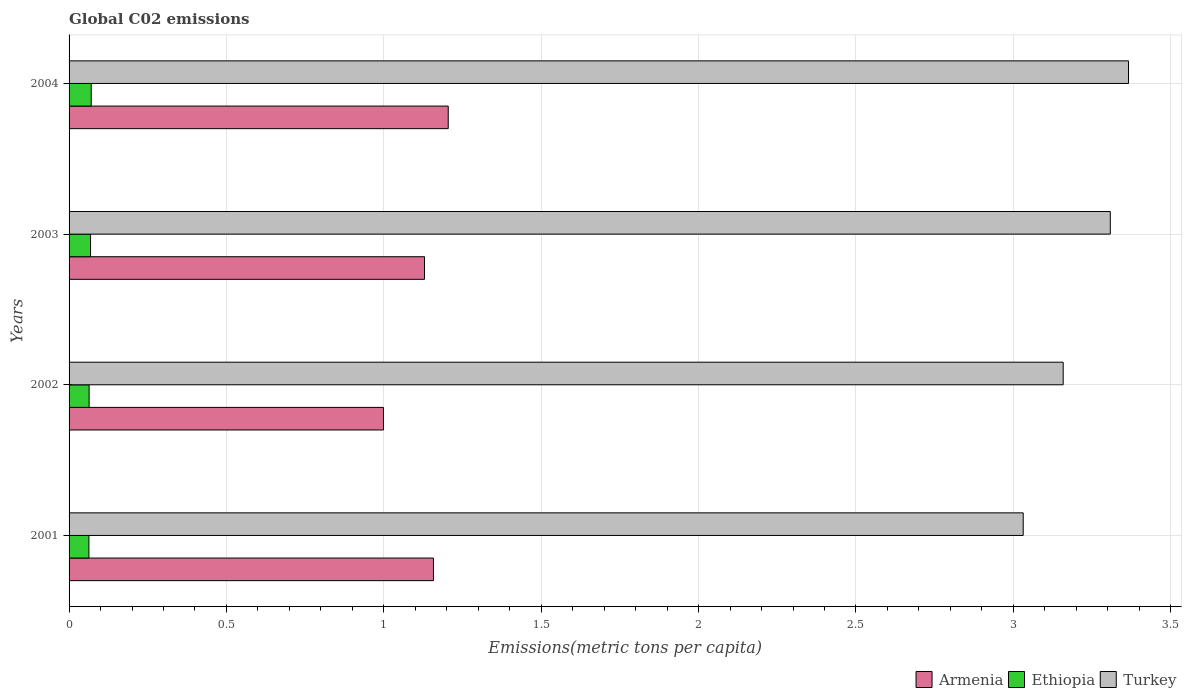How many groups of bars are there?
Your answer should be very brief. 4. Are the number of bars per tick equal to the number of legend labels?
Give a very brief answer. Yes. Are the number of bars on each tick of the Y-axis equal?
Give a very brief answer. Yes. How many bars are there on the 4th tick from the top?
Your answer should be very brief. 3. In how many cases, is the number of bars for a given year not equal to the number of legend labels?
Provide a short and direct response. 0. What is the amount of CO2 emitted in in Turkey in 2004?
Your answer should be compact. 3.37. Across all years, what is the maximum amount of CO2 emitted in in Armenia?
Make the answer very short. 1.2. Across all years, what is the minimum amount of CO2 emitted in in Armenia?
Your answer should be compact. 1. In which year was the amount of CO2 emitted in in Ethiopia maximum?
Offer a terse response. 2004. In which year was the amount of CO2 emitted in in Armenia minimum?
Keep it short and to the point. 2002. What is the total amount of CO2 emitted in in Armenia in the graph?
Make the answer very short. 4.49. What is the difference between the amount of CO2 emitted in in Ethiopia in 2002 and that in 2003?
Your answer should be very brief. -0. What is the difference between the amount of CO2 emitted in in Turkey in 2004 and the amount of CO2 emitted in in Armenia in 2003?
Provide a short and direct response. 2.24. What is the average amount of CO2 emitted in in Ethiopia per year?
Give a very brief answer. 0.07. In the year 2004, what is the difference between the amount of CO2 emitted in in Turkey and amount of CO2 emitted in in Armenia?
Offer a terse response. 2.16. What is the ratio of the amount of CO2 emitted in in Ethiopia in 2002 to that in 2003?
Provide a succinct answer. 0.93. Is the amount of CO2 emitted in in Armenia in 2001 less than that in 2004?
Your answer should be very brief. Yes. What is the difference between the highest and the second highest amount of CO2 emitted in in Turkey?
Make the answer very short. 0.06. What is the difference between the highest and the lowest amount of CO2 emitted in in Ethiopia?
Ensure brevity in your answer.  0.01. In how many years, is the amount of CO2 emitted in in Turkey greater than the average amount of CO2 emitted in in Turkey taken over all years?
Offer a terse response. 2. Is the sum of the amount of CO2 emitted in in Turkey in 2001 and 2002 greater than the maximum amount of CO2 emitted in in Ethiopia across all years?
Your answer should be compact. Yes. What does the 3rd bar from the top in 2001 represents?
Make the answer very short. Armenia. What does the 1st bar from the bottom in 2002 represents?
Offer a terse response. Armenia. How many years are there in the graph?
Provide a succinct answer. 4. What is the difference between two consecutive major ticks on the X-axis?
Your response must be concise. 0.5. Are the values on the major ticks of X-axis written in scientific E-notation?
Your response must be concise. No. Does the graph contain any zero values?
Keep it short and to the point. No. Where does the legend appear in the graph?
Offer a terse response. Bottom right. How many legend labels are there?
Your answer should be compact. 3. How are the legend labels stacked?
Make the answer very short. Horizontal. What is the title of the graph?
Ensure brevity in your answer.  Global C02 emissions. What is the label or title of the X-axis?
Keep it short and to the point. Emissions(metric tons per capita). What is the label or title of the Y-axis?
Your answer should be very brief. Years. What is the Emissions(metric tons per capita) in Armenia in 2001?
Give a very brief answer. 1.16. What is the Emissions(metric tons per capita) of Ethiopia in 2001?
Provide a short and direct response. 0.06. What is the Emissions(metric tons per capita) in Turkey in 2001?
Offer a terse response. 3.03. What is the Emissions(metric tons per capita) in Armenia in 2002?
Give a very brief answer. 1. What is the Emissions(metric tons per capita) in Ethiopia in 2002?
Offer a terse response. 0.06. What is the Emissions(metric tons per capita) of Turkey in 2002?
Give a very brief answer. 3.16. What is the Emissions(metric tons per capita) of Armenia in 2003?
Your answer should be compact. 1.13. What is the Emissions(metric tons per capita) of Ethiopia in 2003?
Provide a succinct answer. 0.07. What is the Emissions(metric tons per capita) of Turkey in 2003?
Make the answer very short. 3.31. What is the Emissions(metric tons per capita) in Armenia in 2004?
Provide a succinct answer. 1.2. What is the Emissions(metric tons per capita) in Ethiopia in 2004?
Offer a very short reply. 0.07. What is the Emissions(metric tons per capita) in Turkey in 2004?
Provide a succinct answer. 3.37. Across all years, what is the maximum Emissions(metric tons per capita) of Armenia?
Your answer should be very brief. 1.2. Across all years, what is the maximum Emissions(metric tons per capita) in Ethiopia?
Your response must be concise. 0.07. Across all years, what is the maximum Emissions(metric tons per capita) of Turkey?
Your answer should be compact. 3.37. Across all years, what is the minimum Emissions(metric tons per capita) of Armenia?
Ensure brevity in your answer.  1. Across all years, what is the minimum Emissions(metric tons per capita) of Ethiopia?
Keep it short and to the point. 0.06. Across all years, what is the minimum Emissions(metric tons per capita) of Turkey?
Keep it short and to the point. 3.03. What is the total Emissions(metric tons per capita) in Armenia in the graph?
Provide a succinct answer. 4.49. What is the total Emissions(metric tons per capita) in Ethiopia in the graph?
Offer a very short reply. 0.27. What is the total Emissions(metric tons per capita) in Turkey in the graph?
Ensure brevity in your answer.  12.86. What is the difference between the Emissions(metric tons per capita) of Armenia in 2001 and that in 2002?
Your answer should be very brief. 0.16. What is the difference between the Emissions(metric tons per capita) in Ethiopia in 2001 and that in 2002?
Your answer should be very brief. -0. What is the difference between the Emissions(metric tons per capita) of Turkey in 2001 and that in 2002?
Give a very brief answer. -0.13. What is the difference between the Emissions(metric tons per capita) in Armenia in 2001 and that in 2003?
Ensure brevity in your answer.  0.03. What is the difference between the Emissions(metric tons per capita) of Ethiopia in 2001 and that in 2003?
Provide a succinct answer. -0.01. What is the difference between the Emissions(metric tons per capita) of Turkey in 2001 and that in 2003?
Your answer should be compact. -0.28. What is the difference between the Emissions(metric tons per capita) of Armenia in 2001 and that in 2004?
Provide a succinct answer. -0.05. What is the difference between the Emissions(metric tons per capita) of Ethiopia in 2001 and that in 2004?
Provide a succinct answer. -0.01. What is the difference between the Emissions(metric tons per capita) in Turkey in 2001 and that in 2004?
Offer a very short reply. -0.33. What is the difference between the Emissions(metric tons per capita) in Armenia in 2002 and that in 2003?
Ensure brevity in your answer.  -0.13. What is the difference between the Emissions(metric tons per capita) of Ethiopia in 2002 and that in 2003?
Give a very brief answer. -0. What is the difference between the Emissions(metric tons per capita) in Turkey in 2002 and that in 2003?
Offer a very short reply. -0.15. What is the difference between the Emissions(metric tons per capita) in Armenia in 2002 and that in 2004?
Give a very brief answer. -0.21. What is the difference between the Emissions(metric tons per capita) of Ethiopia in 2002 and that in 2004?
Provide a short and direct response. -0.01. What is the difference between the Emissions(metric tons per capita) of Turkey in 2002 and that in 2004?
Your answer should be compact. -0.21. What is the difference between the Emissions(metric tons per capita) of Armenia in 2003 and that in 2004?
Your answer should be compact. -0.08. What is the difference between the Emissions(metric tons per capita) of Ethiopia in 2003 and that in 2004?
Your answer should be compact. -0. What is the difference between the Emissions(metric tons per capita) of Turkey in 2003 and that in 2004?
Offer a terse response. -0.06. What is the difference between the Emissions(metric tons per capita) in Armenia in 2001 and the Emissions(metric tons per capita) in Ethiopia in 2002?
Offer a very short reply. 1.09. What is the difference between the Emissions(metric tons per capita) in Armenia in 2001 and the Emissions(metric tons per capita) in Turkey in 2002?
Provide a succinct answer. -2. What is the difference between the Emissions(metric tons per capita) of Ethiopia in 2001 and the Emissions(metric tons per capita) of Turkey in 2002?
Provide a short and direct response. -3.1. What is the difference between the Emissions(metric tons per capita) of Armenia in 2001 and the Emissions(metric tons per capita) of Ethiopia in 2003?
Make the answer very short. 1.09. What is the difference between the Emissions(metric tons per capita) in Armenia in 2001 and the Emissions(metric tons per capita) in Turkey in 2003?
Your answer should be very brief. -2.15. What is the difference between the Emissions(metric tons per capita) of Ethiopia in 2001 and the Emissions(metric tons per capita) of Turkey in 2003?
Provide a short and direct response. -3.25. What is the difference between the Emissions(metric tons per capita) in Armenia in 2001 and the Emissions(metric tons per capita) in Ethiopia in 2004?
Offer a very short reply. 1.09. What is the difference between the Emissions(metric tons per capita) of Armenia in 2001 and the Emissions(metric tons per capita) of Turkey in 2004?
Provide a short and direct response. -2.21. What is the difference between the Emissions(metric tons per capita) of Ethiopia in 2001 and the Emissions(metric tons per capita) of Turkey in 2004?
Offer a very short reply. -3.3. What is the difference between the Emissions(metric tons per capita) in Armenia in 2002 and the Emissions(metric tons per capita) in Ethiopia in 2003?
Provide a short and direct response. 0.93. What is the difference between the Emissions(metric tons per capita) in Armenia in 2002 and the Emissions(metric tons per capita) in Turkey in 2003?
Provide a succinct answer. -2.31. What is the difference between the Emissions(metric tons per capita) of Ethiopia in 2002 and the Emissions(metric tons per capita) of Turkey in 2003?
Give a very brief answer. -3.24. What is the difference between the Emissions(metric tons per capita) of Armenia in 2002 and the Emissions(metric tons per capita) of Ethiopia in 2004?
Your response must be concise. 0.93. What is the difference between the Emissions(metric tons per capita) of Armenia in 2002 and the Emissions(metric tons per capita) of Turkey in 2004?
Your answer should be compact. -2.37. What is the difference between the Emissions(metric tons per capita) in Ethiopia in 2002 and the Emissions(metric tons per capita) in Turkey in 2004?
Provide a succinct answer. -3.3. What is the difference between the Emissions(metric tons per capita) in Armenia in 2003 and the Emissions(metric tons per capita) in Ethiopia in 2004?
Your response must be concise. 1.06. What is the difference between the Emissions(metric tons per capita) of Armenia in 2003 and the Emissions(metric tons per capita) of Turkey in 2004?
Your answer should be compact. -2.24. What is the difference between the Emissions(metric tons per capita) in Ethiopia in 2003 and the Emissions(metric tons per capita) in Turkey in 2004?
Make the answer very short. -3.3. What is the average Emissions(metric tons per capita) of Armenia per year?
Keep it short and to the point. 1.12. What is the average Emissions(metric tons per capita) in Ethiopia per year?
Give a very brief answer. 0.07. What is the average Emissions(metric tons per capita) in Turkey per year?
Your answer should be very brief. 3.22. In the year 2001, what is the difference between the Emissions(metric tons per capita) in Armenia and Emissions(metric tons per capita) in Ethiopia?
Ensure brevity in your answer.  1.09. In the year 2001, what is the difference between the Emissions(metric tons per capita) in Armenia and Emissions(metric tons per capita) in Turkey?
Make the answer very short. -1.87. In the year 2001, what is the difference between the Emissions(metric tons per capita) in Ethiopia and Emissions(metric tons per capita) in Turkey?
Your response must be concise. -2.97. In the year 2002, what is the difference between the Emissions(metric tons per capita) in Armenia and Emissions(metric tons per capita) in Ethiopia?
Your answer should be very brief. 0.94. In the year 2002, what is the difference between the Emissions(metric tons per capita) of Armenia and Emissions(metric tons per capita) of Turkey?
Your response must be concise. -2.16. In the year 2002, what is the difference between the Emissions(metric tons per capita) of Ethiopia and Emissions(metric tons per capita) of Turkey?
Your response must be concise. -3.09. In the year 2003, what is the difference between the Emissions(metric tons per capita) of Armenia and Emissions(metric tons per capita) of Ethiopia?
Give a very brief answer. 1.06. In the year 2003, what is the difference between the Emissions(metric tons per capita) in Armenia and Emissions(metric tons per capita) in Turkey?
Provide a short and direct response. -2.18. In the year 2003, what is the difference between the Emissions(metric tons per capita) of Ethiopia and Emissions(metric tons per capita) of Turkey?
Give a very brief answer. -3.24. In the year 2004, what is the difference between the Emissions(metric tons per capita) of Armenia and Emissions(metric tons per capita) of Ethiopia?
Your response must be concise. 1.13. In the year 2004, what is the difference between the Emissions(metric tons per capita) in Armenia and Emissions(metric tons per capita) in Turkey?
Provide a succinct answer. -2.16. In the year 2004, what is the difference between the Emissions(metric tons per capita) in Ethiopia and Emissions(metric tons per capita) in Turkey?
Provide a succinct answer. -3.3. What is the ratio of the Emissions(metric tons per capita) of Armenia in 2001 to that in 2002?
Offer a terse response. 1.16. What is the ratio of the Emissions(metric tons per capita) of Turkey in 2001 to that in 2002?
Offer a terse response. 0.96. What is the ratio of the Emissions(metric tons per capita) of Armenia in 2001 to that in 2003?
Offer a terse response. 1.03. What is the ratio of the Emissions(metric tons per capita) in Ethiopia in 2001 to that in 2003?
Give a very brief answer. 0.92. What is the ratio of the Emissions(metric tons per capita) of Turkey in 2001 to that in 2003?
Your answer should be very brief. 0.92. What is the ratio of the Emissions(metric tons per capita) in Armenia in 2001 to that in 2004?
Keep it short and to the point. 0.96. What is the ratio of the Emissions(metric tons per capita) in Ethiopia in 2001 to that in 2004?
Keep it short and to the point. 0.9. What is the ratio of the Emissions(metric tons per capita) of Turkey in 2001 to that in 2004?
Your answer should be compact. 0.9. What is the ratio of the Emissions(metric tons per capita) in Armenia in 2002 to that in 2003?
Ensure brevity in your answer.  0.88. What is the ratio of the Emissions(metric tons per capita) of Ethiopia in 2002 to that in 2003?
Offer a very short reply. 0.93. What is the ratio of the Emissions(metric tons per capita) in Turkey in 2002 to that in 2003?
Your response must be concise. 0.95. What is the ratio of the Emissions(metric tons per capita) in Armenia in 2002 to that in 2004?
Provide a succinct answer. 0.83. What is the ratio of the Emissions(metric tons per capita) in Ethiopia in 2002 to that in 2004?
Give a very brief answer. 0.9. What is the ratio of the Emissions(metric tons per capita) in Turkey in 2002 to that in 2004?
Offer a terse response. 0.94. What is the ratio of the Emissions(metric tons per capita) in Armenia in 2003 to that in 2004?
Keep it short and to the point. 0.94. What is the ratio of the Emissions(metric tons per capita) of Ethiopia in 2003 to that in 2004?
Keep it short and to the point. 0.97. What is the ratio of the Emissions(metric tons per capita) in Turkey in 2003 to that in 2004?
Your answer should be compact. 0.98. What is the difference between the highest and the second highest Emissions(metric tons per capita) of Armenia?
Make the answer very short. 0.05. What is the difference between the highest and the second highest Emissions(metric tons per capita) of Ethiopia?
Give a very brief answer. 0. What is the difference between the highest and the second highest Emissions(metric tons per capita) in Turkey?
Offer a terse response. 0.06. What is the difference between the highest and the lowest Emissions(metric tons per capita) of Armenia?
Provide a short and direct response. 0.21. What is the difference between the highest and the lowest Emissions(metric tons per capita) of Ethiopia?
Keep it short and to the point. 0.01. What is the difference between the highest and the lowest Emissions(metric tons per capita) in Turkey?
Your answer should be compact. 0.33. 